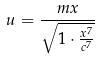Convert formula to latex. <formula><loc_0><loc_0><loc_500><loc_500>u = \frac { m x } { \sqrt { 1 \cdot \frac { x ^ { 7 } } { c ^ { 7 } } } }</formula> 